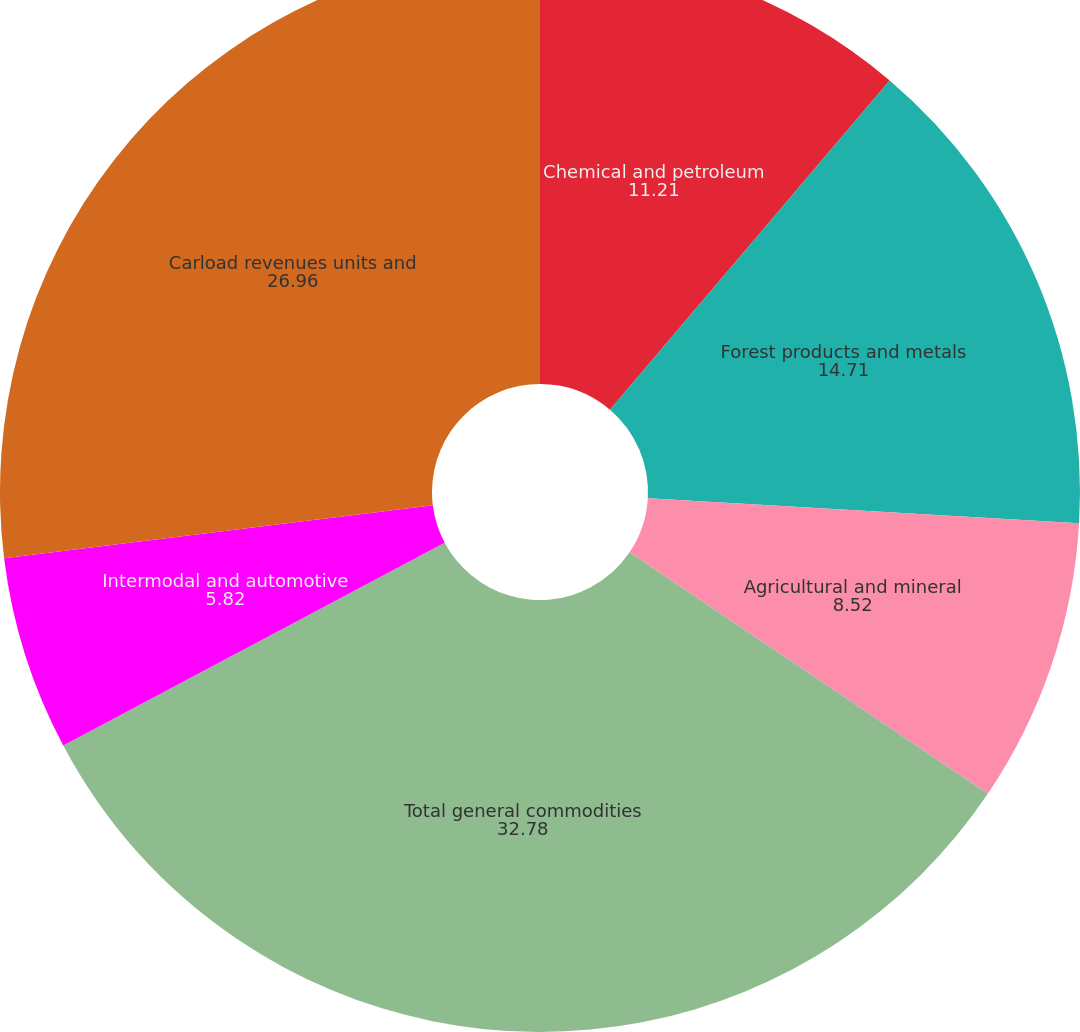Convert chart to OTSL. <chart><loc_0><loc_0><loc_500><loc_500><pie_chart><fcel>Chemical and petroleum<fcel>Forest products and metals<fcel>Agricultural and mineral<fcel>Total general commodities<fcel>Intermodal and automotive<fcel>Carload revenues units and<nl><fcel>11.21%<fcel>14.71%<fcel>8.52%<fcel>32.78%<fcel>5.82%<fcel>26.96%<nl></chart> 